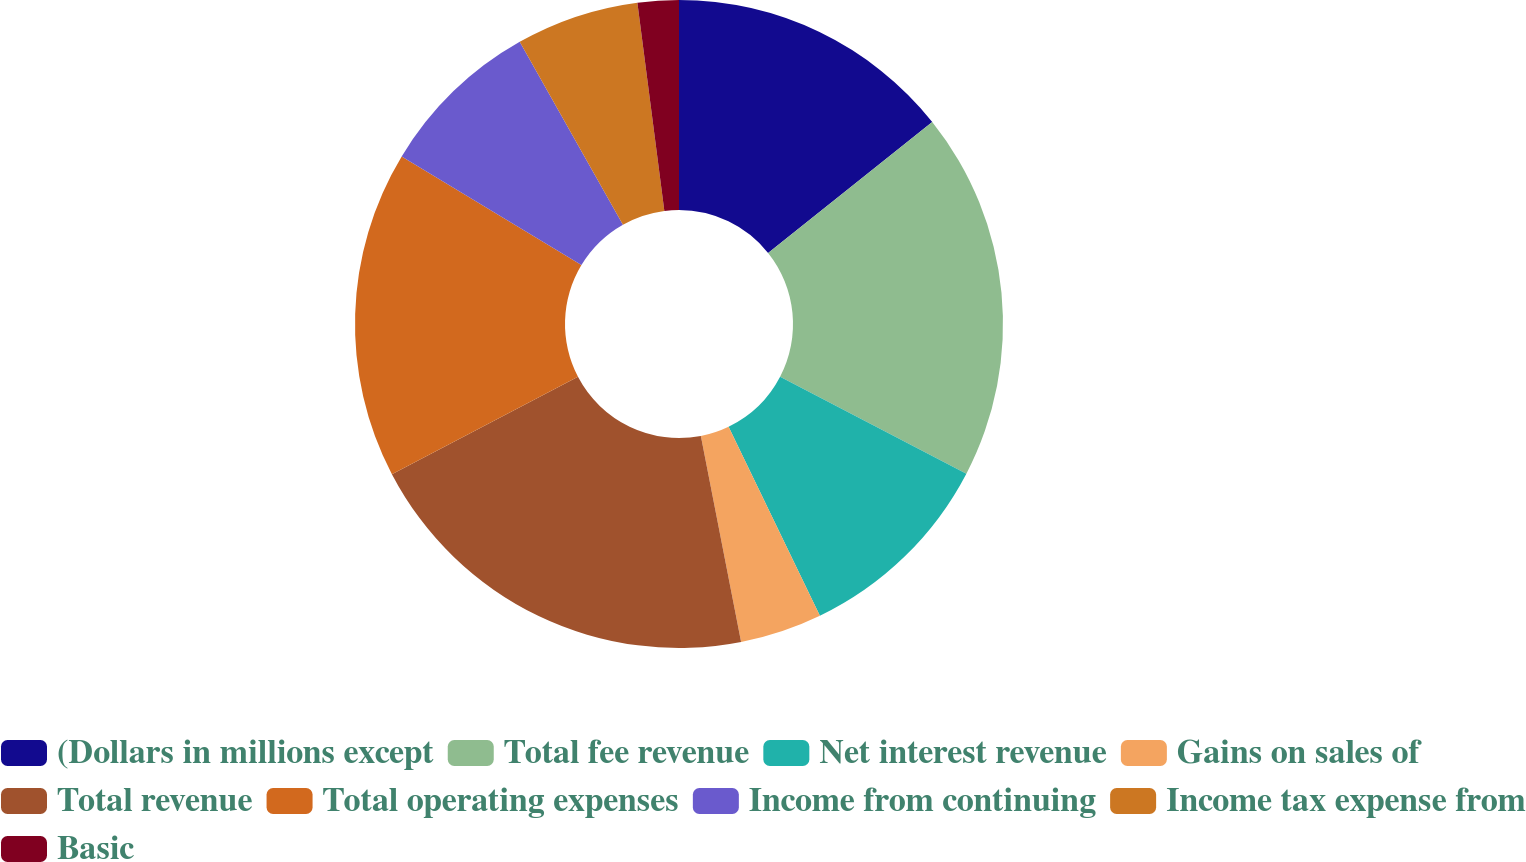Convert chart. <chart><loc_0><loc_0><loc_500><loc_500><pie_chart><fcel>(Dollars in millions except<fcel>Total fee revenue<fcel>Net interest revenue<fcel>Gains on sales of<fcel>Total revenue<fcel>Total operating expenses<fcel>Income from continuing<fcel>Income tax expense from<fcel>Basic<nl><fcel>14.28%<fcel>18.36%<fcel>10.2%<fcel>4.09%<fcel>20.4%<fcel>16.32%<fcel>8.17%<fcel>6.13%<fcel>2.05%<nl></chart> 